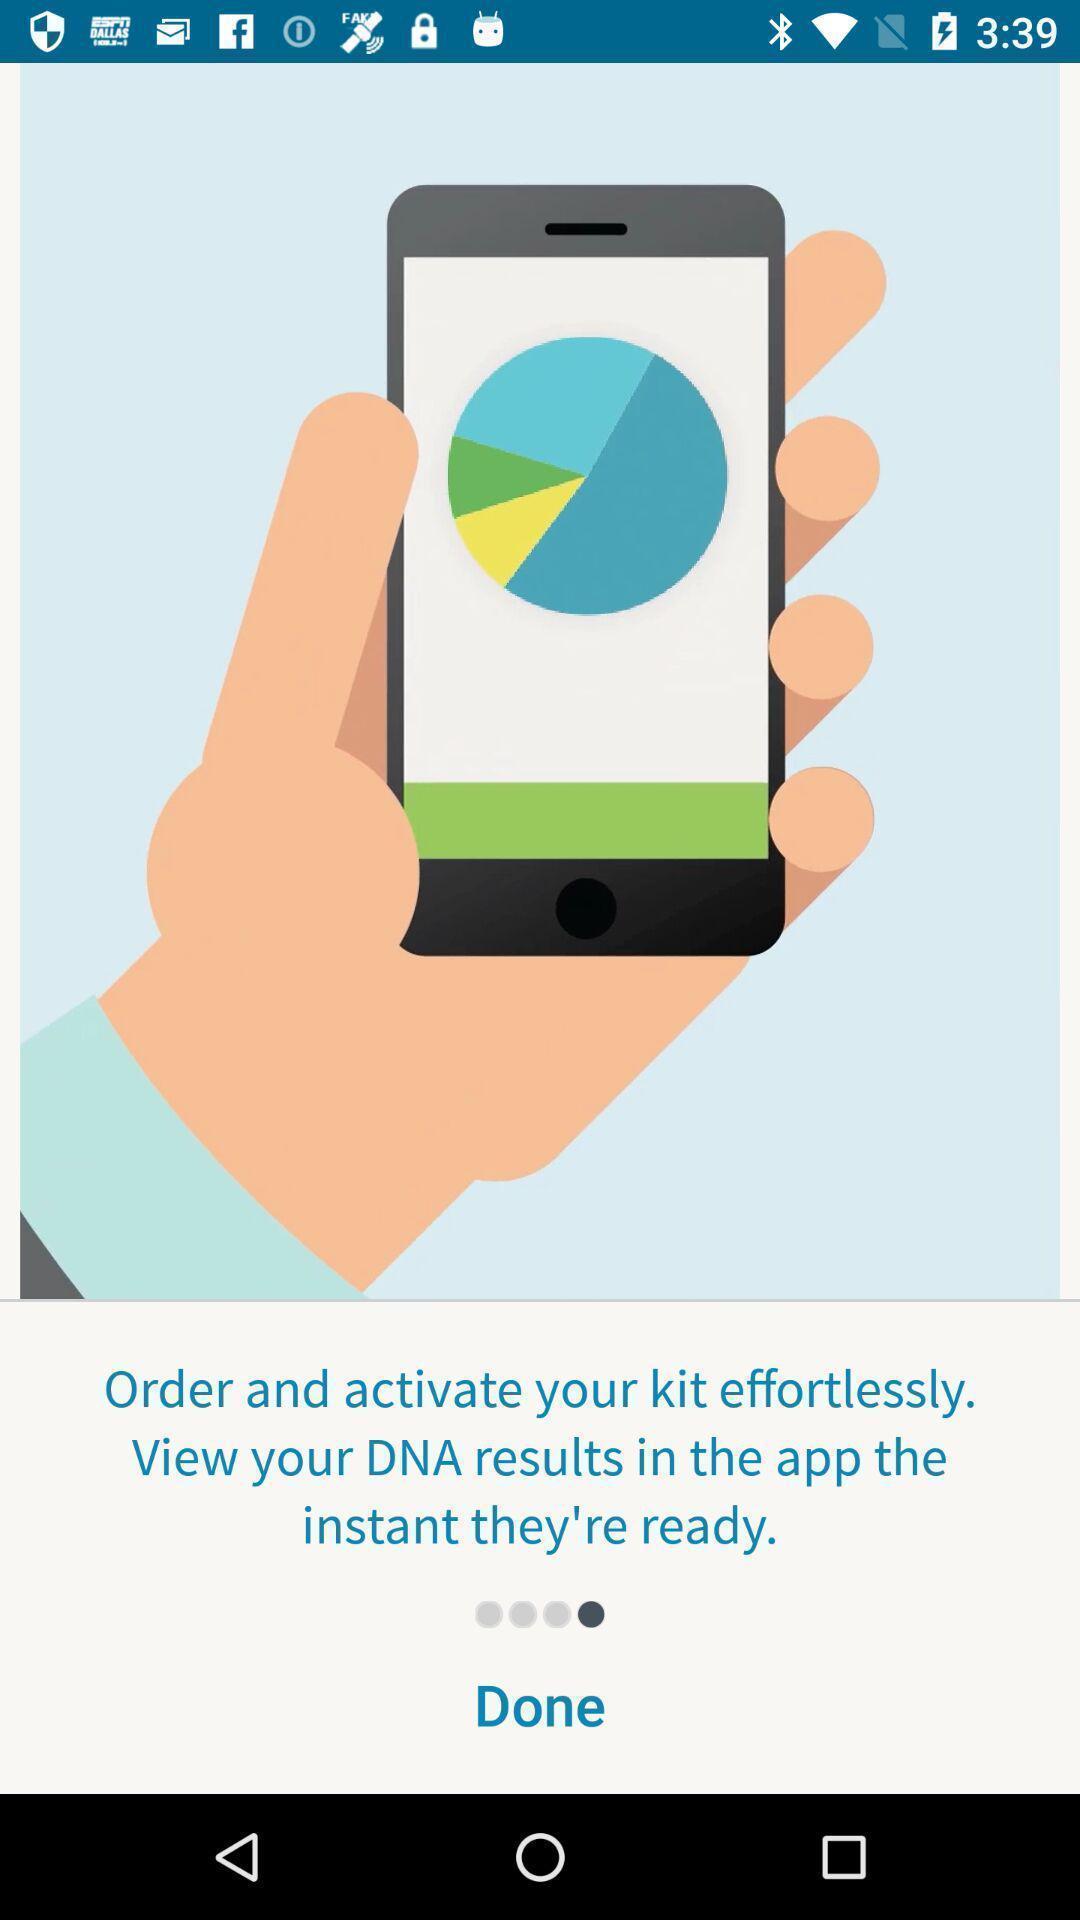Provide a textual representation of this image. Screen displaying information about an application. 